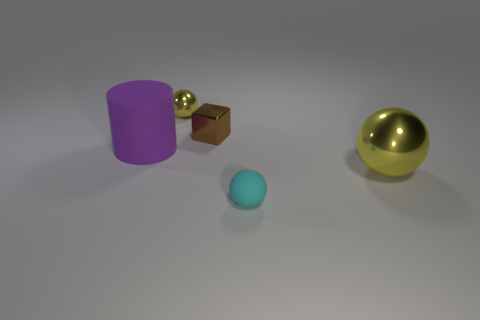Subtract all tiny metallic spheres. How many spheres are left? 2 Subtract 1 cylinders. How many cylinders are left? 0 Subtract all cyan spheres. How many spheres are left? 2 Subtract all balls. How many objects are left? 2 Add 2 large brown shiny blocks. How many objects exist? 7 Subtract all cyan rubber balls. Subtract all tiny yellow metal balls. How many objects are left? 3 Add 5 matte objects. How many matte objects are left? 7 Add 2 big metal balls. How many big metal balls exist? 3 Subtract 1 brown blocks. How many objects are left? 4 Subtract all red balls. Subtract all brown blocks. How many balls are left? 3 